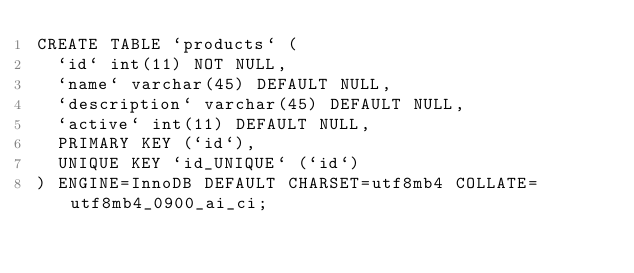Convert code to text. <code><loc_0><loc_0><loc_500><loc_500><_SQL_>CREATE TABLE `products` (
  `id` int(11) NOT NULL,
  `name` varchar(45) DEFAULT NULL,
  `description` varchar(45) DEFAULT NULL,
  `active` int(11) DEFAULT NULL,
  PRIMARY KEY (`id`),
  UNIQUE KEY `id_UNIQUE` (`id`)
) ENGINE=InnoDB DEFAULT CHARSET=utf8mb4 COLLATE=utf8mb4_0900_ai_ci;</code> 